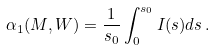Convert formula to latex. <formula><loc_0><loc_0><loc_500><loc_500>\alpha _ { 1 } ( M , W ) = \frac { 1 } { s _ { 0 } } \int _ { 0 } ^ { s _ { 0 } } I ( s ) d s \, .</formula> 